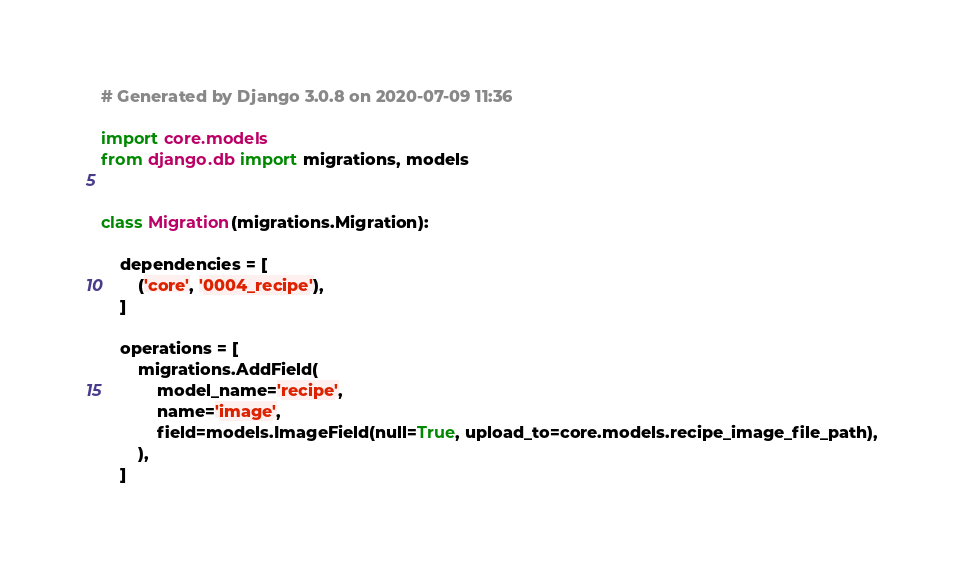<code> <loc_0><loc_0><loc_500><loc_500><_Python_># Generated by Django 3.0.8 on 2020-07-09 11:36

import core.models
from django.db import migrations, models


class Migration(migrations.Migration):

    dependencies = [
        ('core', '0004_recipe'),
    ]

    operations = [
        migrations.AddField(
            model_name='recipe',
            name='image',
            field=models.ImageField(null=True, upload_to=core.models.recipe_image_file_path),
        ),
    ]
</code> 